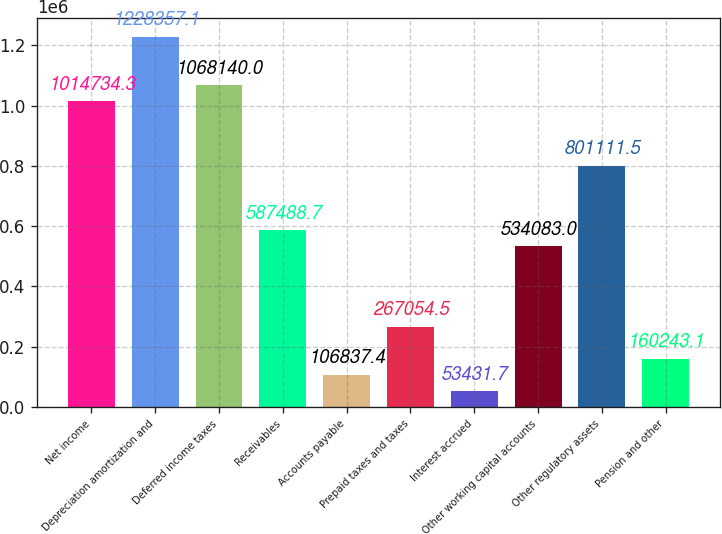Convert chart to OTSL. <chart><loc_0><loc_0><loc_500><loc_500><bar_chart><fcel>Net income<fcel>Depreciation amortization and<fcel>Deferred income taxes<fcel>Receivables<fcel>Accounts payable<fcel>Prepaid taxes and taxes<fcel>Interest accrued<fcel>Other working capital accounts<fcel>Other regulatory assets<fcel>Pension and other<nl><fcel>1.01473e+06<fcel>1.22836e+06<fcel>1.06814e+06<fcel>587489<fcel>106837<fcel>267054<fcel>53431.7<fcel>534083<fcel>801112<fcel>160243<nl></chart> 